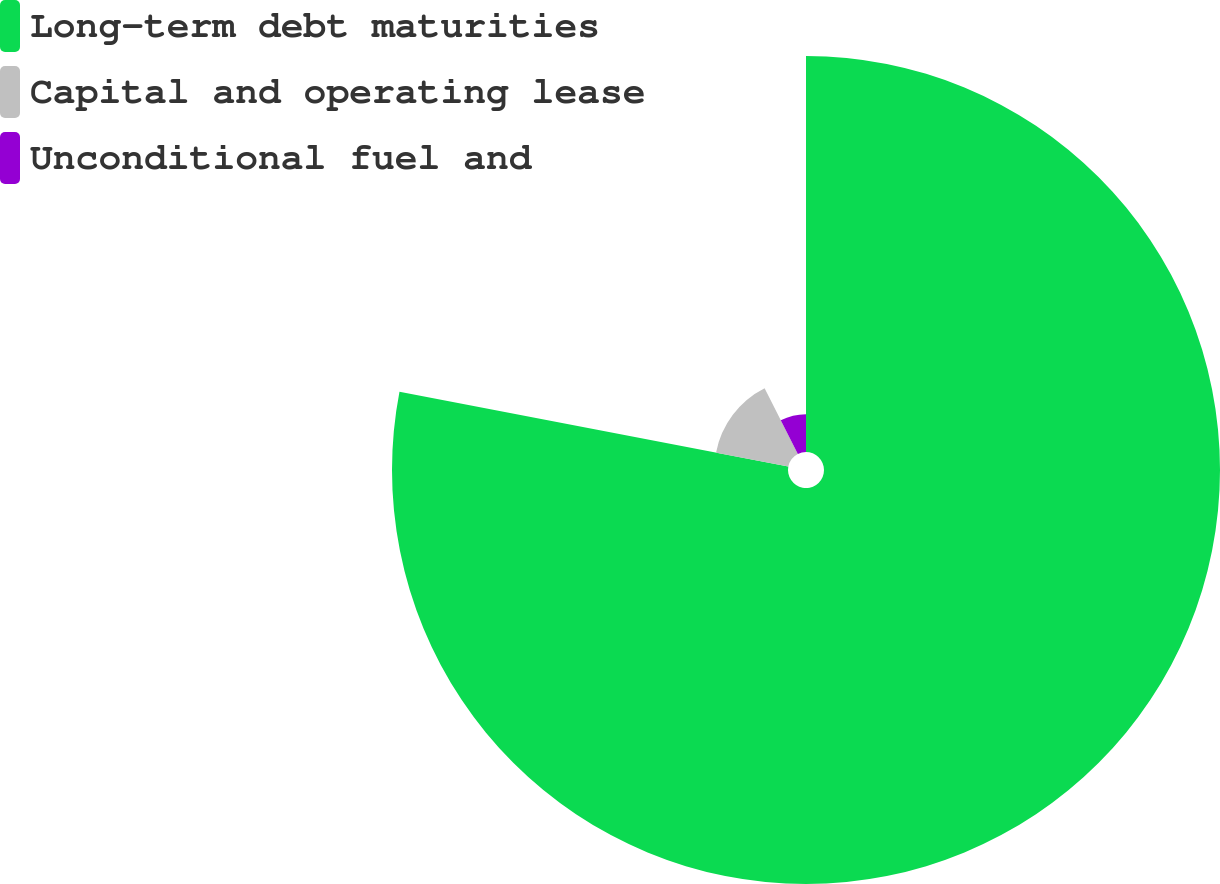Convert chart. <chart><loc_0><loc_0><loc_500><loc_500><pie_chart><fcel>Long-term debt maturities<fcel>Capital and operating lease<fcel>Unconditional fuel and<nl><fcel>78.03%<fcel>14.51%<fcel>7.46%<nl></chart> 